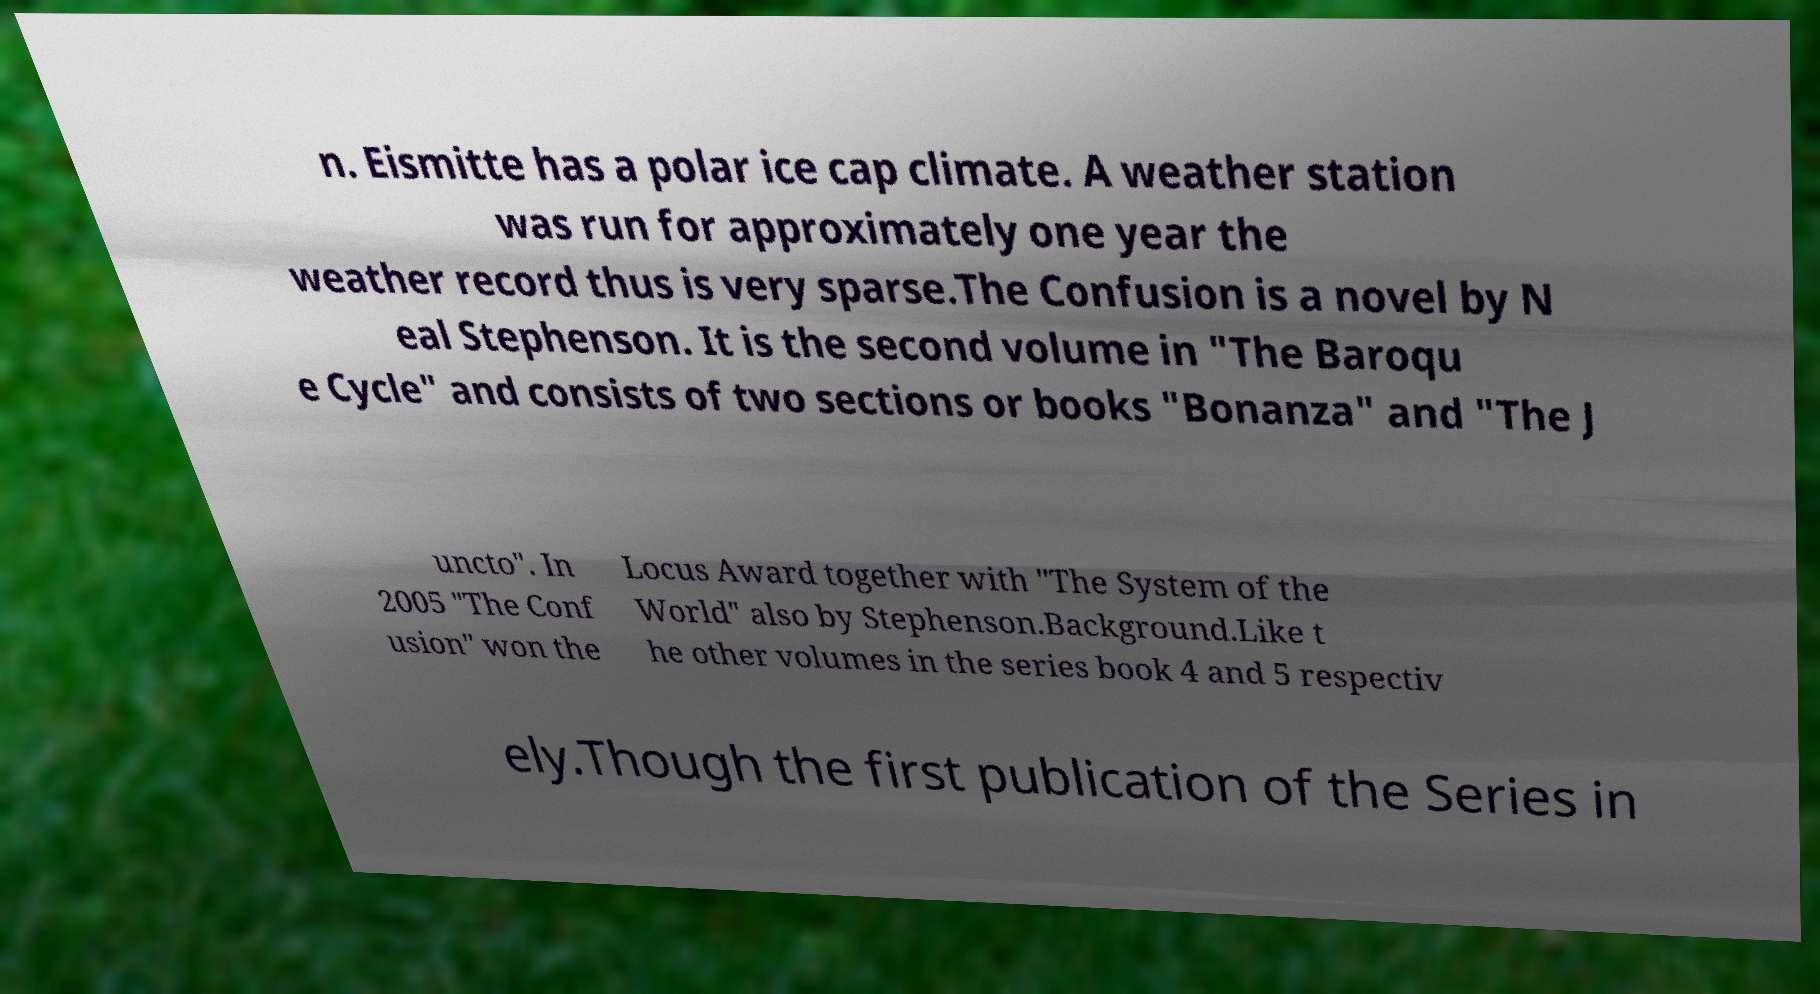There's text embedded in this image that I need extracted. Can you transcribe it verbatim? n. Eismitte has a polar ice cap climate. A weather station was run for approximately one year the weather record thus is very sparse.The Confusion is a novel by N eal Stephenson. It is the second volume in "The Baroqu e Cycle" and consists of two sections or books "Bonanza" and "The J uncto". In 2005 "The Conf usion" won the Locus Award together with "The System of the World" also by Stephenson.Background.Like t he other volumes in the series book 4 and 5 respectiv ely.Though the first publication of the Series in 